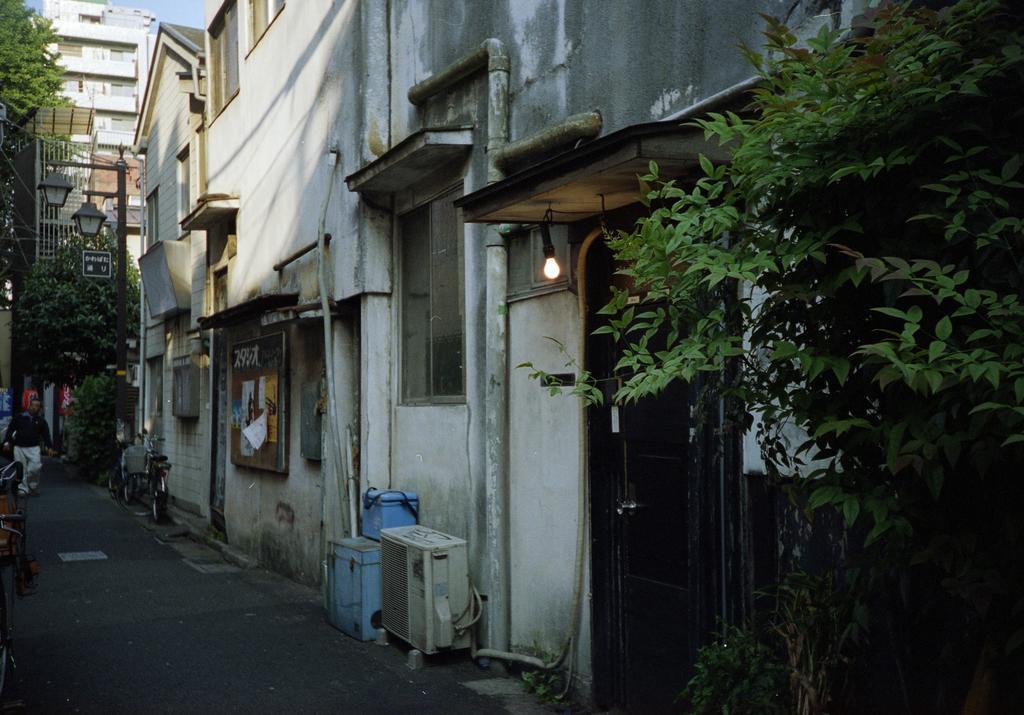Could you give a brief overview of what you see in this image? These are the buildings with the windows and doors. This looks like a board, which is attached to the building wall. I can see a bulb hanging to the roof. This is a pipe, which is attached to the wall. I can see the trees. This looks like a street light. Here is a bicycle, which is parked. I can see a person walking on the road. 